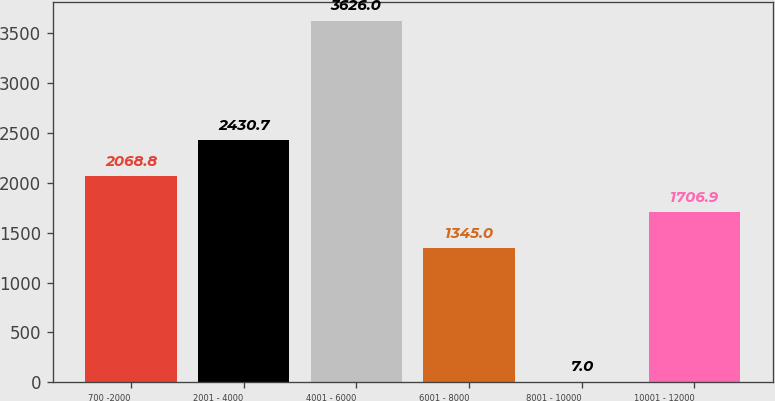Convert chart. <chart><loc_0><loc_0><loc_500><loc_500><bar_chart><fcel>700 -2000<fcel>2001 - 4000<fcel>4001 - 6000<fcel>6001 - 8000<fcel>8001 - 10000<fcel>10001 - 12000<nl><fcel>2068.8<fcel>2430.7<fcel>3626<fcel>1345<fcel>7<fcel>1706.9<nl></chart> 